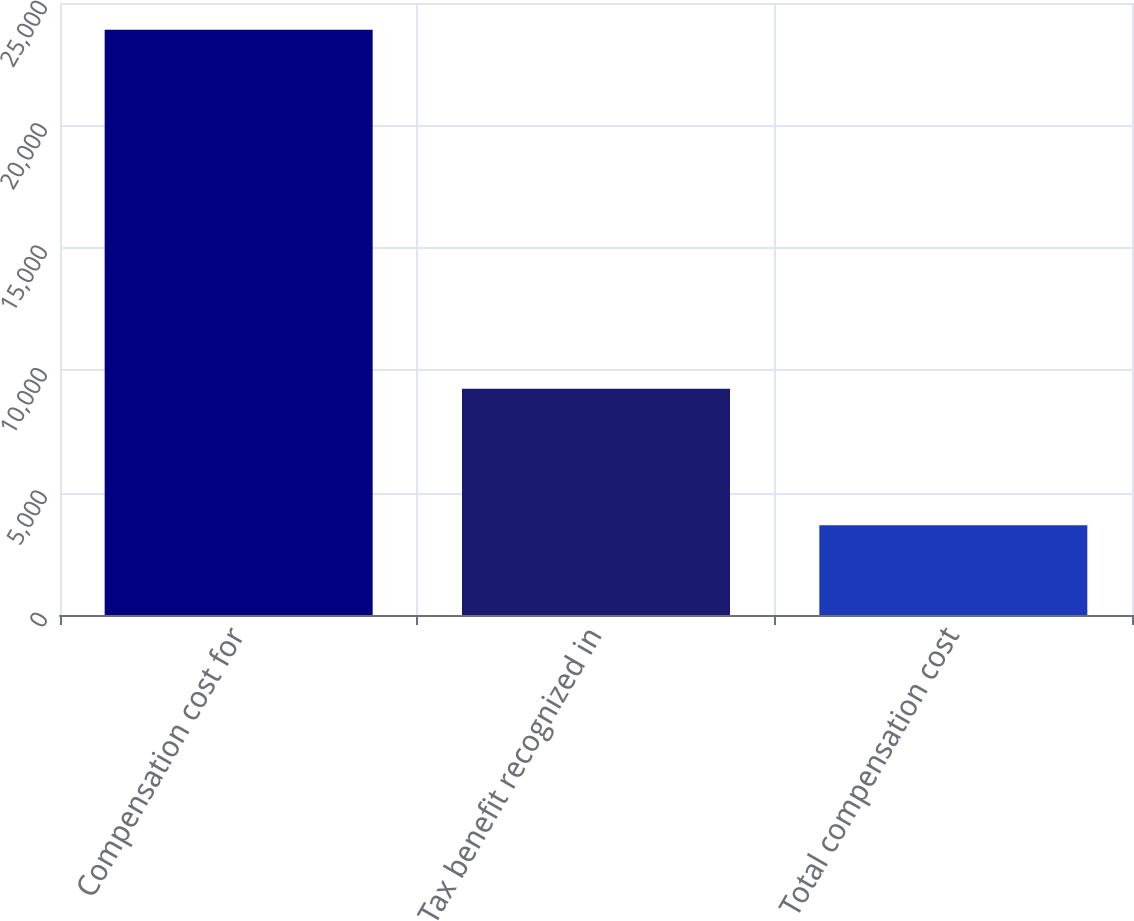<chart> <loc_0><loc_0><loc_500><loc_500><bar_chart><fcel>Compensation cost for<fcel>Tax benefit recognized in<fcel>Total compensation cost<nl><fcel>23912<fcel>9241<fcel>3666<nl></chart> 